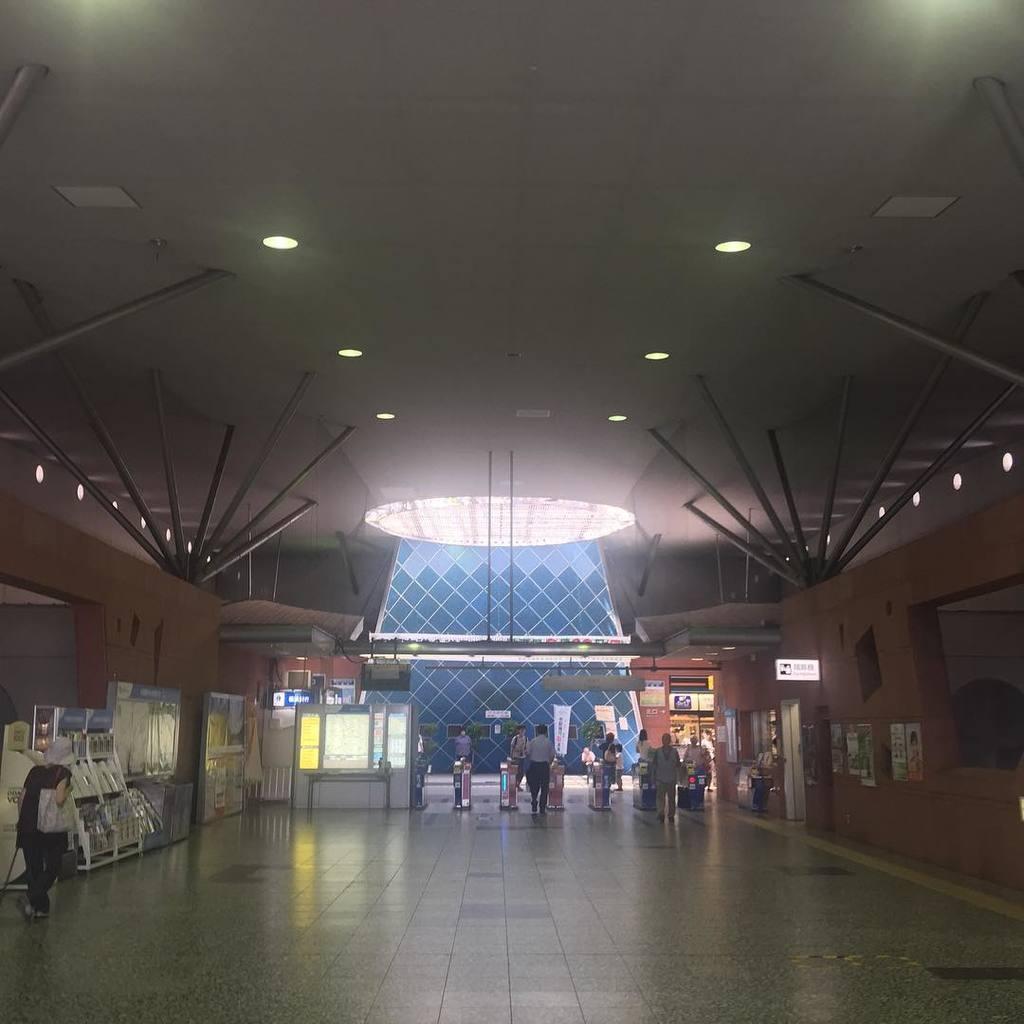How would you summarize this image in a sentence or two? In the image in the center we can see few people were standing. And we can see banners,screens,posters,sign boards,machines and few other objects. In the background there is a wall,roof and lights. 